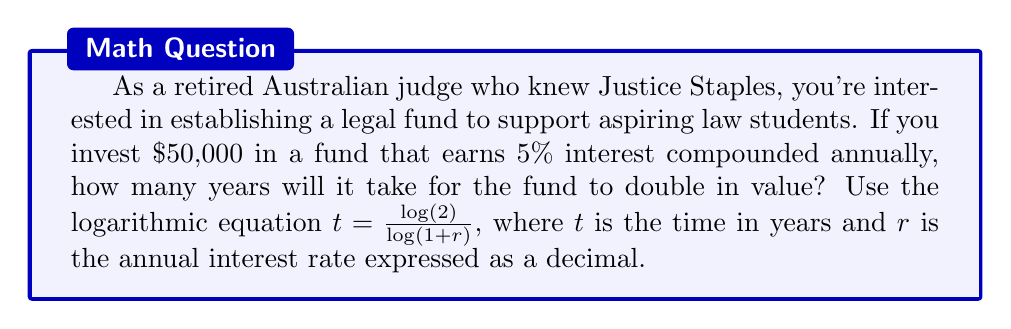Give your solution to this math problem. To solve this problem, we'll use the logarithmic equation for the time it takes an investment to double:

$$t = \frac{\log(2)}{\log(1 + r)}$$

Where:
$t$ is the time in years
$r$ is the annual interest rate expressed as a decimal

Given:
- Initial investment: $50,000 (not needed for calculation)
- Interest rate: 5% annually, so $r = 0.05$

Step 1: Substitute the given interest rate into the equation.
$$t = \frac{\log(2)}{\log(1 + 0.05)}$$

Step 2: Calculate the denominator.
$$t = \frac{\log(2)}{\log(1.05)}$$

Step 3: Use a calculator or logarithm tables to evaluate the logarithms.
$$t = \frac{0.30103}{0.02119}$$

Step 4: Divide the numerator by the denominator.
$$t = 14.2061$$

Step 5: Round to the nearest hundredth, as we're dealing with years.
$$t \approx 14.21 \text{ years}$$
Answer: It will take approximately 14.21 years for the legal fund to double in value. 